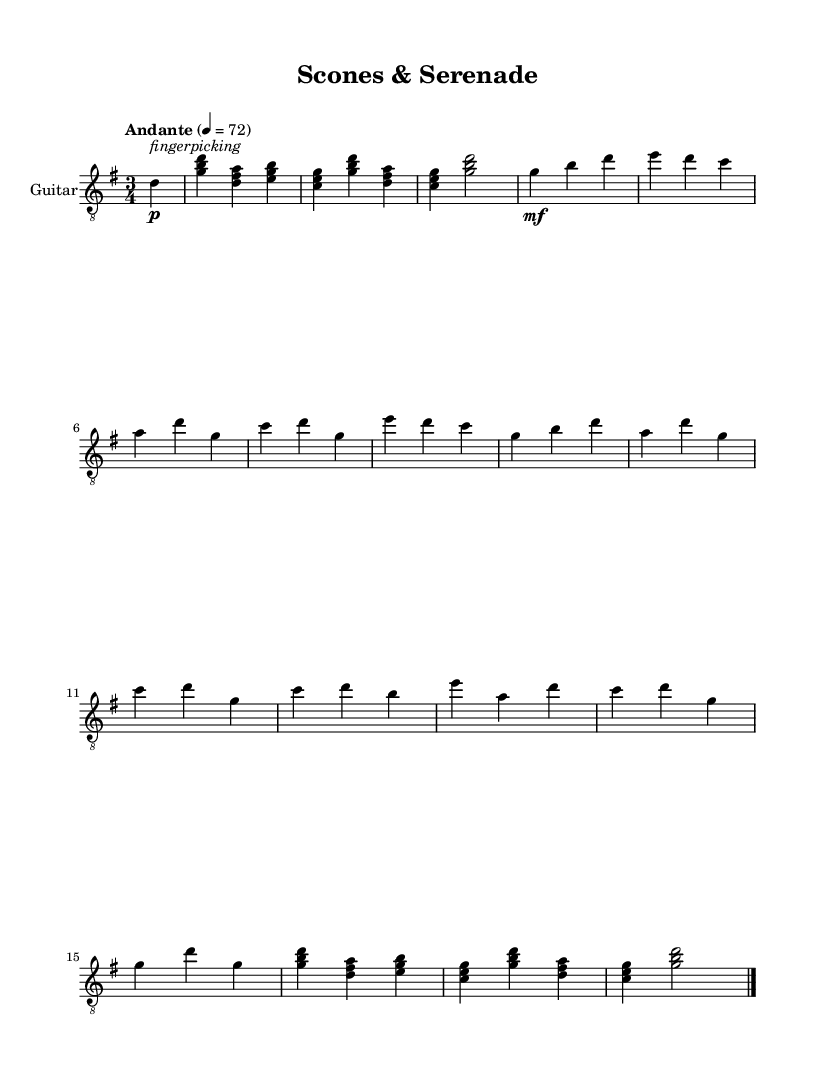What is the key signature of this music? The key signature is G major, which has one sharp (F#). This can be determined by looking at the key signature indicator at the beginning of the staff where the symbol for F# is shown.
Answer: G major What is the time signature of this piece? The time signature is 3/4, indicated at the beginning of the sheet music. It suggests that there are three beats in each measure and the quarter note receives one beat.
Answer: 3/4 What tempo marking is indicated for this piece? The tempo marking is "Andante," which indicates a moderately slow pace. This is expressed in words near the tempo indication, giving a qualitative measure of the intended speed.
Answer: Andante How many measures are in Section A? Section A consists of 4 measures, which can be counted by looking at the divisions in the music section, indicated by the bar lines marking the end of each measure.
Answer: 4 How many different sections does the piece have? The piece has three main sections labeled A, B, and C, identified by the naming conventions in the format of the music, illustrating the distinct thematic parts of the composition.
Answer: 3 What guitar technique is indicated at the start of the piece? The technique indicated is "fingerpicking," shown as a markup instruction beside the first note. It suggests the manner in which the performer is meant to pluck the strings.
Answer: fingerpicking What is the final chord of the piece? The final chord of the piece is a G major chord, which is formed by the notes G, B, and D. This is represented in the last measure of the sheet music where these notes are played.
Answer: G major 